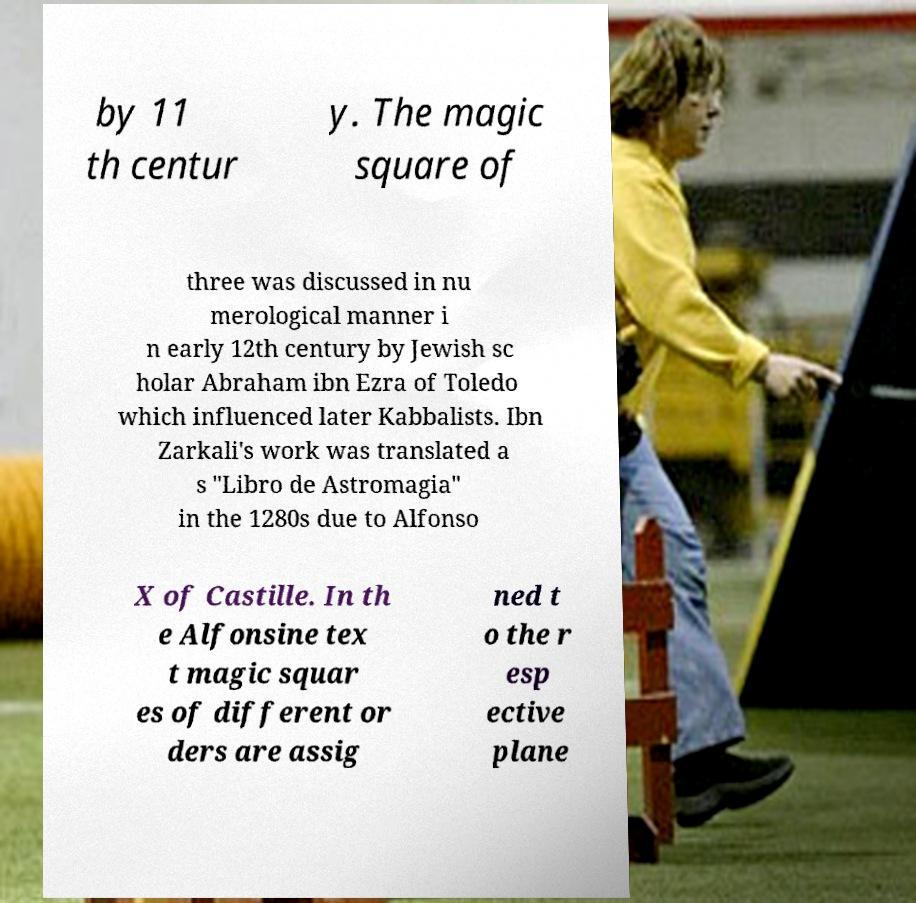Could you extract and type out the text from this image? by 11 th centur y. The magic square of three was discussed in nu merological manner i n early 12th century by Jewish sc holar Abraham ibn Ezra of Toledo which influenced later Kabbalists. Ibn Zarkali's work was translated a s "Libro de Astromagia" in the 1280s due to Alfonso X of Castille. In th e Alfonsine tex t magic squar es of different or ders are assig ned t o the r esp ective plane 